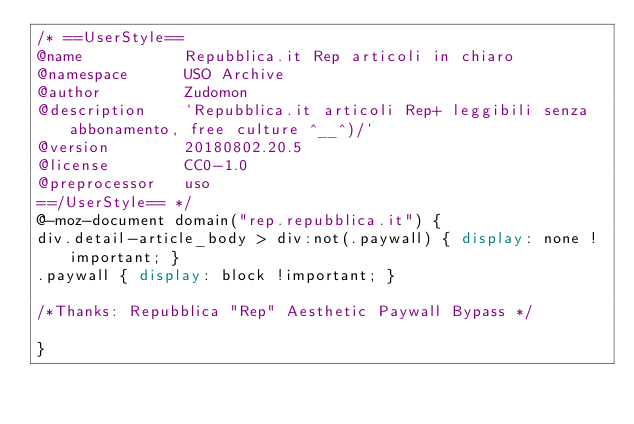<code> <loc_0><loc_0><loc_500><loc_500><_CSS_>/* ==UserStyle==
@name           Repubblica.it Rep articoli in chiaro
@namespace      USO Archive
@author         Zudomon
@description    `Repubblica.it articoli Rep+ leggibili senza abbonamento, free culture ^__^)/`
@version        20180802.20.5
@license        CC0-1.0
@preprocessor   uso
==/UserStyle== */
@-moz-document domain("rep.repubblica.it") {
div.detail-article_body > div:not(.paywall) { display: none !important; }
.paywall { display: block !important; }

/*Thanks: Repubblica "Rep" Aesthetic Paywall Bypass */

}</code> 